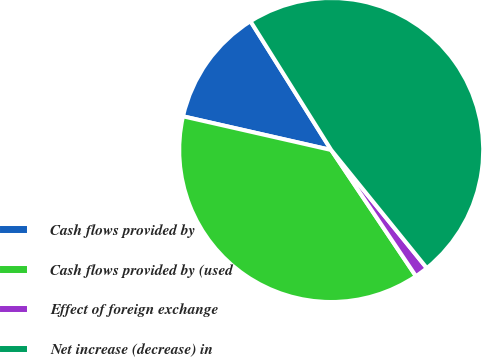Convert chart. <chart><loc_0><loc_0><loc_500><loc_500><pie_chart><fcel>Cash flows provided by<fcel>Cash flows provided by (used<fcel>Effect of foreign exchange<fcel>Net increase (decrease) in<nl><fcel>12.53%<fcel>37.97%<fcel>1.42%<fcel>48.08%<nl></chart> 